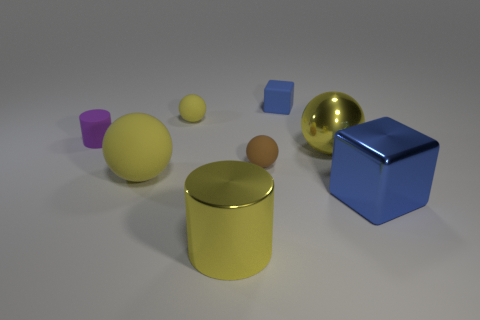Is there another cylinder that has the same size as the yellow cylinder?
Offer a very short reply. No. Do the large blue object and the yellow object that is right of the tiny brown matte thing have the same shape?
Offer a very short reply. No. There is a yellow rubber ball that is in front of the tiny rubber cylinder; does it have the same size as the yellow thing that is behind the small purple rubber cylinder?
Your answer should be compact. No. How many other things are the same shape as the big matte object?
Keep it short and to the point. 3. There is a blue cube that is behind the blue block in front of the brown thing; what is its material?
Give a very brief answer. Rubber. What number of rubber objects are either gray blocks or small yellow things?
Ensure brevity in your answer.  1. Is there a blue block in front of the big object left of the large shiny cylinder?
Provide a short and direct response. Yes. How many things are either big yellow metal cylinders that are to the right of the small yellow sphere or blue blocks behind the tiny yellow object?
Make the answer very short. 2. Are there any other things that have the same color as the small cylinder?
Keep it short and to the point. No. There is a big object that is to the right of the large metal thing that is behind the yellow matte sphere that is to the left of the tiny yellow thing; what color is it?
Ensure brevity in your answer.  Blue. 